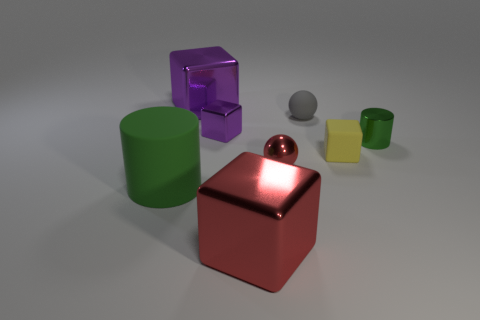Subtract all tiny purple blocks. How many blocks are left? 3 Add 1 big green matte things. How many objects exist? 9 Subtract all red balls. How many balls are left? 1 Subtract all red cylinders. How many purple cubes are left? 2 Subtract all cylinders. How many objects are left? 6 Subtract 1 cubes. How many cubes are left? 3 Subtract all yellow cubes. Subtract all red cylinders. How many cubes are left? 3 Subtract all brown matte cubes. Subtract all green shiny things. How many objects are left? 7 Add 6 rubber things. How many rubber things are left? 9 Add 7 purple shiny objects. How many purple shiny objects exist? 9 